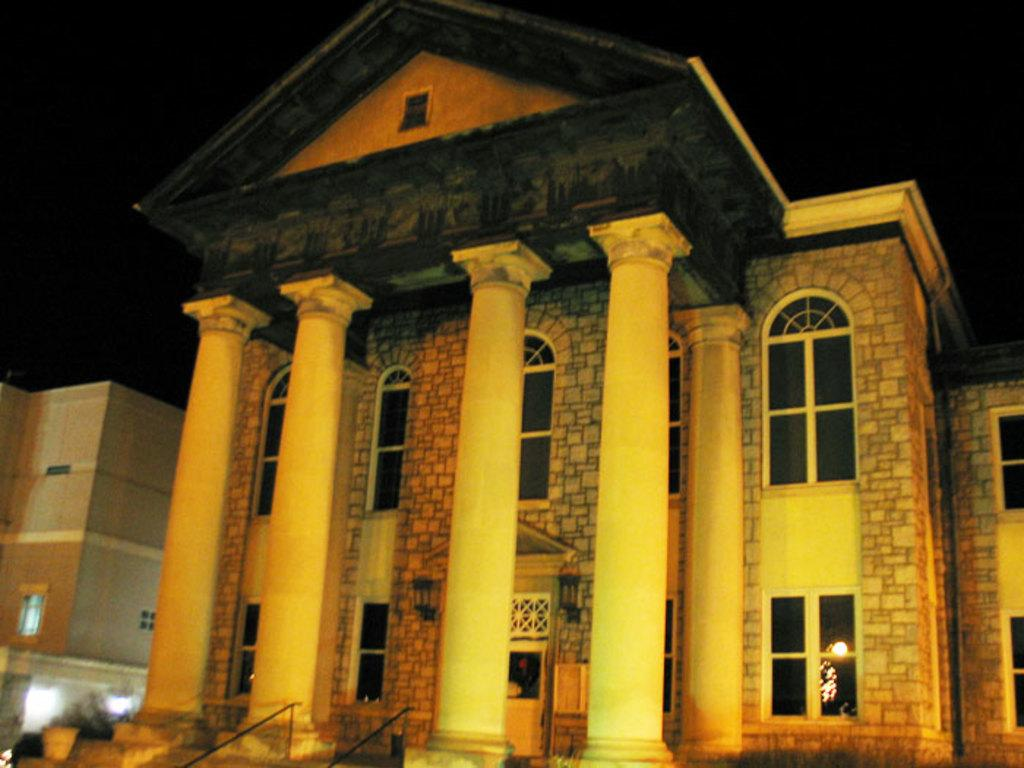What type of structure is visible in the image? There is a building with windows in the image. What architectural features can be seen on the building? The building has pillars. Is there more than one building in the image? Yes, there is another building on the left side of the image. What is the color of the background in the image? The background of the image is dark. What type of holiday is being celebrated in the image? There is no indication of a holiday being celebrated in the image. What kind of trouble is the building experiencing in the image? There is no indication of any trouble or issue with the building in the image. 